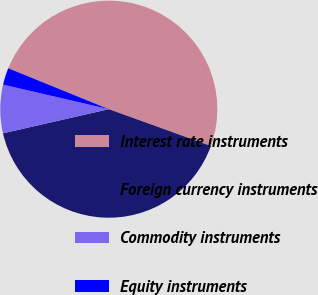Convert chart to OTSL. <chart><loc_0><loc_0><loc_500><loc_500><pie_chart><fcel>Interest rate instruments<fcel>Foreign currency instruments<fcel>Commodity instruments<fcel>Equity instruments<nl><fcel>49.36%<fcel>40.91%<fcel>7.2%<fcel>2.52%<nl></chart> 